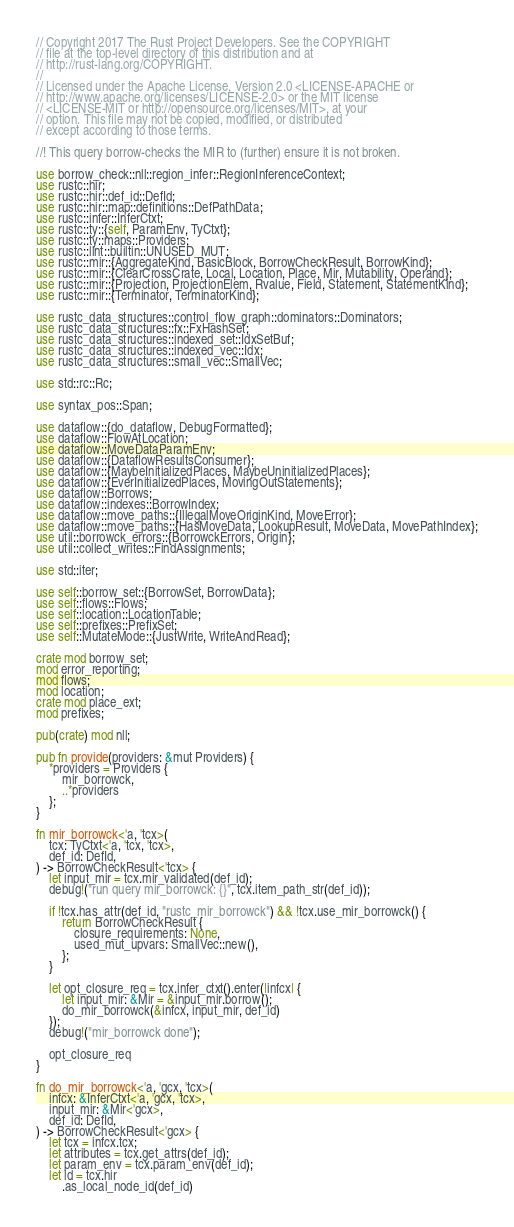Convert code to text. <code><loc_0><loc_0><loc_500><loc_500><_Rust_>// Copyright 2017 The Rust Project Developers. See the COPYRIGHT
// file at the top-level directory of this distribution and at
// http://rust-lang.org/COPYRIGHT.
//
// Licensed under the Apache License, Version 2.0 <LICENSE-APACHE or
// http://www.apache.org/licenses/LICENSE-2.0> or the MIT license
// <LICENSE-MIT or http://opensource.org/licenses/MIT>, at your
// option. This file may not be copied, modified, or distributed
// except according to those terms.

//! This query borrow-checks the MIR to (further) ensure it is not broken.

use borrow_check::nll::region_infer::RegionInferenceContext;
use rustc::hir;
use rustc::hir::def_id::DefId;
use rustc::hir::map::definitions::DefPathData;
use rustc::infer::InferCtxt;
use rustc::ty::{self, ParamEnv, TyCtxt};
use rustc::ty::maps::Providers;
use rustc::lint::builtin::UNUSED_MUT;
use rustc::mir::{AggregateKind, BasicBlock, BorrowCheckResult, BorrowKind};
use rustc::mir::{ClearCrossCrate, Local, Location, Place, Mir, Mutability, Operand};
use rustc::mir::{Projection, ProjectionElem, Rvalue, Field, Statement, StatementKind};
use rustc::mir::{Terminator, TerminatorKind};

use rustc_data_structures::control_flow_graph::dominators::Dominators;
use rustc_data_structures::fx::FxHashSet;
use rustc_data_structures::indexed_set::IdxSetBuf;
use rustc_data_structures::indexed_vec::Idx;
use rustc_data_structures::small_vec::SmallVec;

use std::rc::Rc;

use syntax_pos::Span;

use dataflow::{do_dataflow, DebugFormatted};
use dataflow::FlowAtLocation;
use dataflow::MoveDataParamEnv;
use dataflow::{DataflowResultsConsumer};
use dataflow::{MaybeInitializedPlaces, MaybeUninitializedPlaces};
use dataflow::{EverInitializedPlaces, MovingOutStatements};
use dataflow::Borrows;
use dataflow::indexes::BorrowIndex;
use dataflow::move_paths::{IllegalMoveOriginKind, MoveError};
use dataflow::move_paths::{HasMoveData, LookupResult, MoveData, MovePathIndex};
use util::borrowck_errors::{BorrowckErrors, Origin};
use util::collect_writes::FindAssignments;

use std::iter;

use self::borrow_set::{BorrowSet, BorrowData};
use self::flows::Flows;
use self::location::LocationTable;
use self::prefixes::PrefixSet;
use self::MutateMode::{JustWrite, WriteAndRead};

crate mod borrow_set;
mod error_reporting;
mod flows;
mod location;
crate mod place_ext;
mod prefixes;

pub(crate) mod nll;

pub fn provide(providers: &mut Providers) {
    *providers = Providers {
        mir_borrowck,
        ..*providers
    };
}

fn mir_borrowck<'a, 'tcx>(
    tcx: TyCtxt<'a, 'tcx, 'tcx>,
    def_id: DefId,
) -> BorrowCheckResult<'tcx> {
    let input_mir = tcx.mir_validated(def_id);
    debug!("run query mir_borrowck: {}", tcx.item_path_str(def_id));

    if !tcx.has_attr(def_id, "rustc_mir_borrowck") && !tcx.use_mir_borrowck() {
        return BorrowCheckResult {
            closure_requirements: None,
            used_mut_upvars: SmallVec::new(),
        };
    }

    let opt_closure_req = tcx.infer_ctxt().enter(|infcx| {
        let input_mir: &Mir = &input_mir.borrow();
        do_mir_borrowck(&infcx, input_mir, def_id)
    });
    debug!("mir_borrowck done");

    opt_closure_req
}

fn do_mir_borrowck<'a, 'gcx, 'tcx>(
    infcx: &InferCtxt<'a, 'gcx, 'tcx>,
    input_mir: &Mir<'gcx>,
    def_id: DefId,
) -> BorrowCheckResult<'gcx> {
    let tcx = infcx.tcx;
    let attributes = tcx.get_attrs(def_id);
    let param_env = tcx.param_env(def_id);
    let id = tcx.hir
        .as_local_node_id(def_id)</code> 